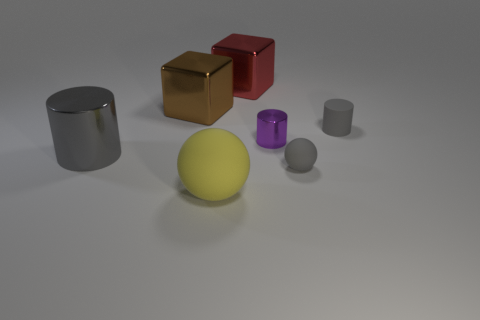There is a tiny rubber object that is the same shape as the big matte object; what is its color?
Provide a succinct answer. Gray. Are there any other things that are the same color as the big matte thing?
Make the answer very short. No. There is a shiny block to the right of the big brown thing; does it have the same size as the gray object that is behind the small purple thing?
Your answer should be very brief. No. Are there an equal number of big brown objects that are to the left of the big cylinder and large brown metallic blocks left of the yellow matte object?
Your answer should be very brief. No. There is a purple cylinder; does it have the same size as the red object behind the big gray cylinder?
Your answer should be compact. No. There is a big metal thing that is to the left of the big brown metallic object; is there a gray ball that is to the left of it?
Make the answer very short. No. Are there any other big objects that have the same shape as the red shiny object?
Provide a succinct answer. Yes. There is a shiny cylinder that is on the right side of the big shiny object to the right of the large ball; what number of gray matte spheres are left of it?
Your answer should be very brief. 0. Does the matte cylinder have the same color as the cylinder in front of the tiny purple cylinder?
Provide a short and direct response. Yes. What number of objects are either large metallic blocks behind the brown object or large things in front of the small purple metallic cylinder?
Keep it short and to the point. 3. 